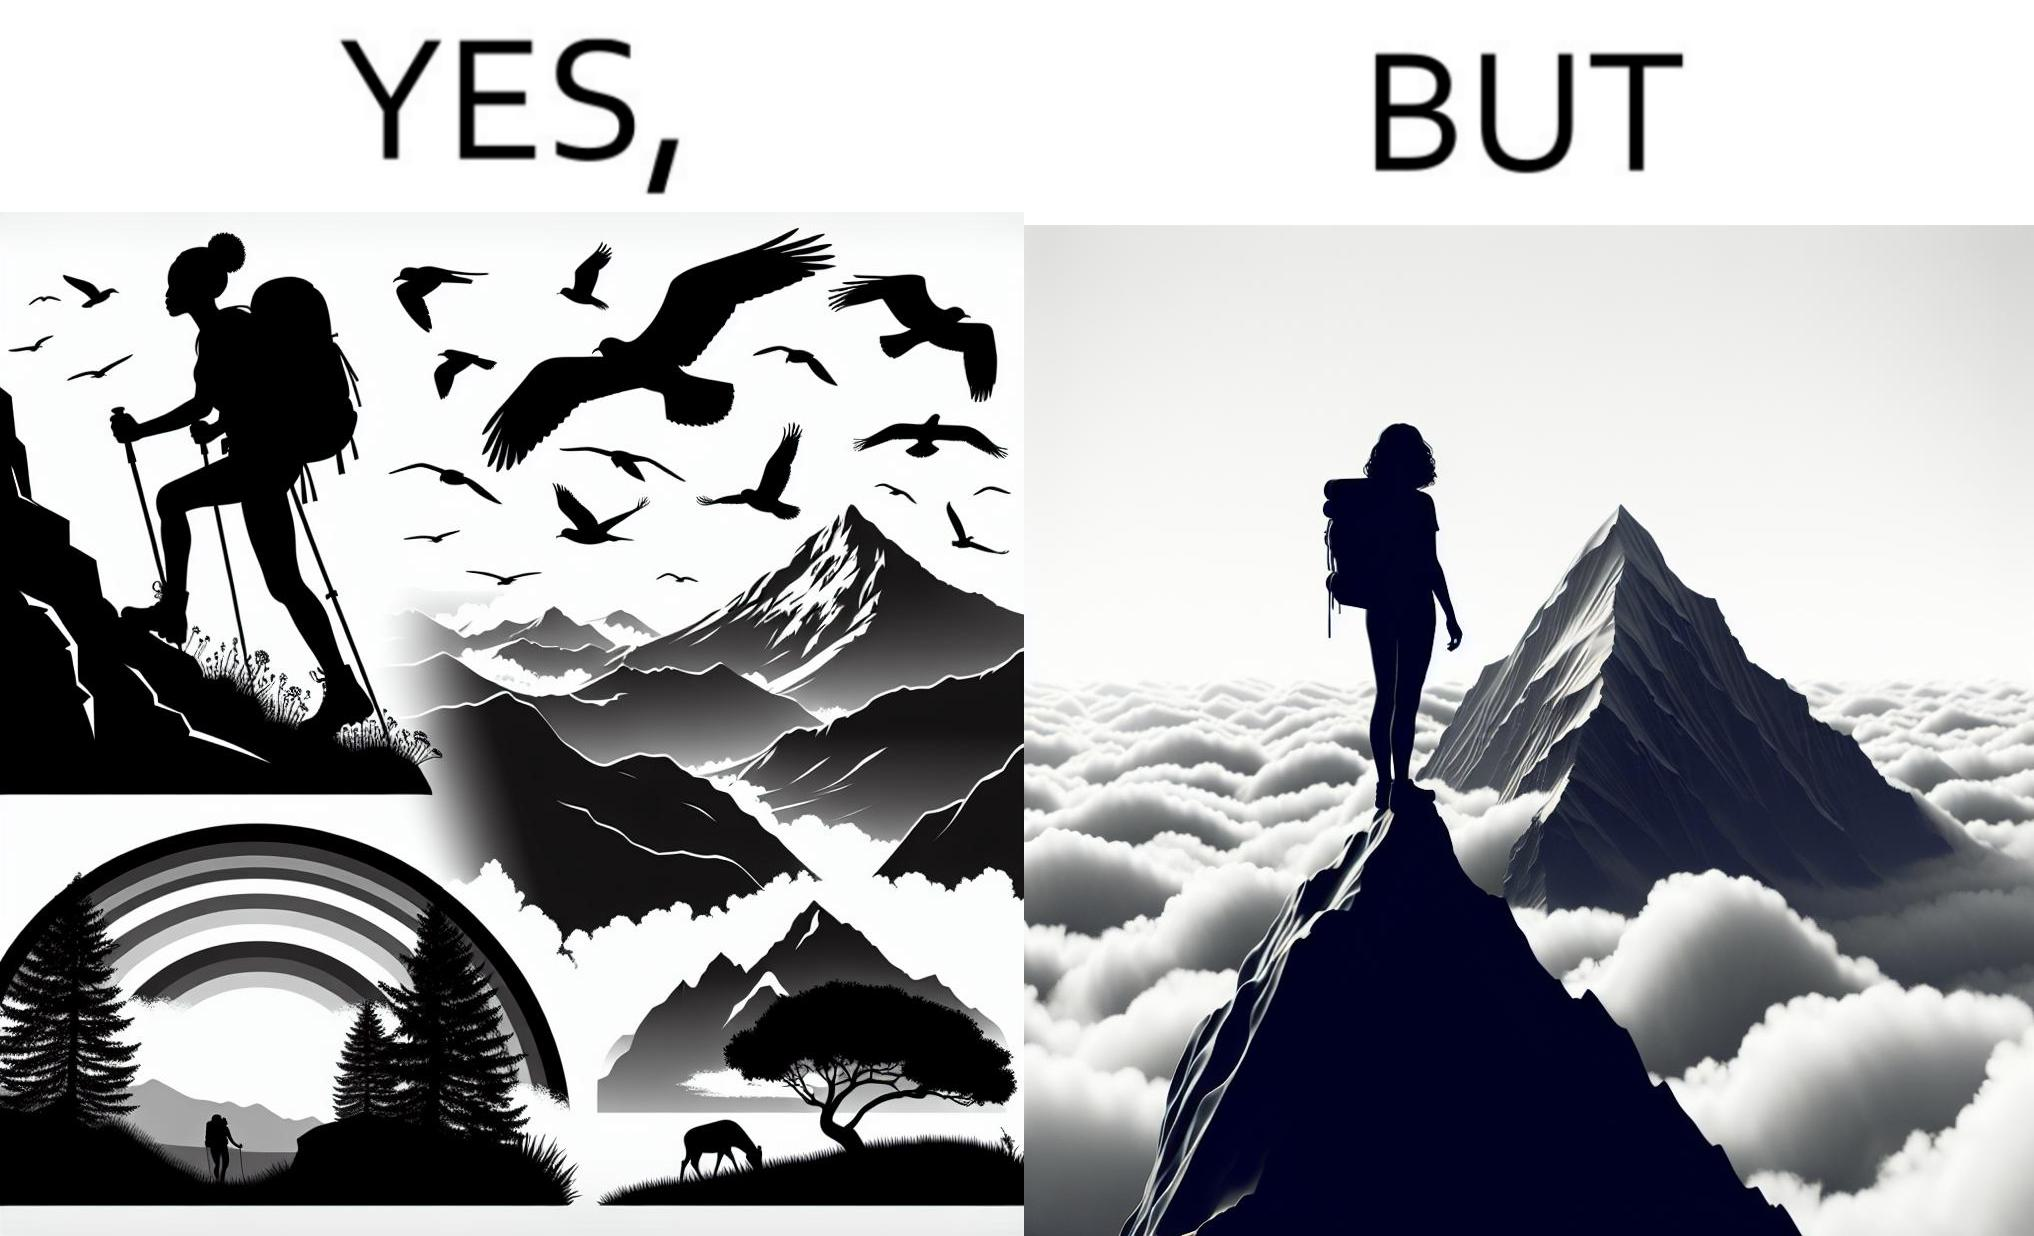What does this image depict? The image is ironic, because the mountaineer climbs up the mountain to view the world from the peak but due to so much cloud, at the top, nothing is visible whereas he was able to witness some awesome views while climbing up the mountain 